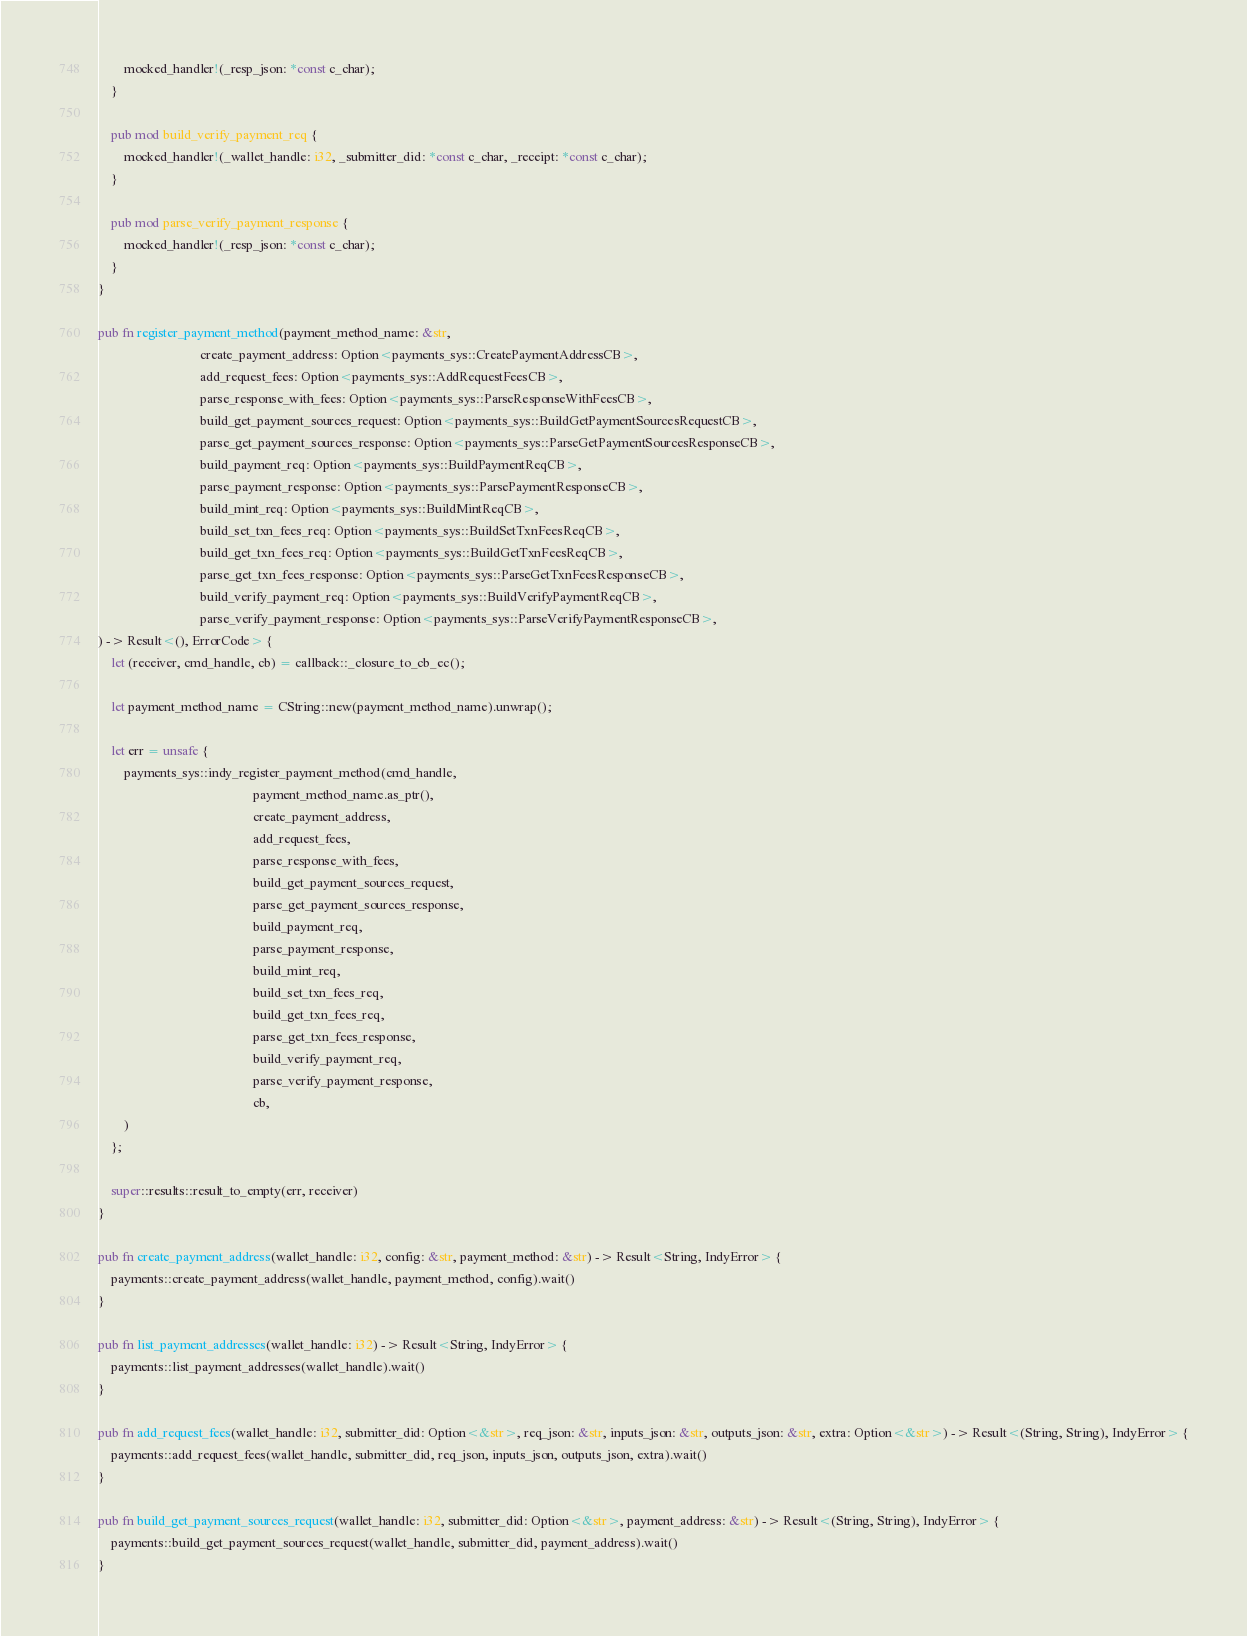Convert code to text. <code><loc_0><loc_0><loc_500><loc_500><_Rust_>        mocked_handler!(_resp_json: *const c_char);
    }

    pub mod build_verify_payment_req {
        mocked_handler!(_wallet_handle: i32, _submitter_did: *const c_char, _receipt: *const c_char);
    }

    pub mod parse_verify_payment_response {
        mocked_handler!(_resp_json: *const c_char);
    }
}

pub fn register_payment_method(payment_method_name: &str,
                               create_payment_address: Option<payments_sys::CreatePaymentAddressCB>,
                               add_request_fees: Option<payments_sys::AddRequestFeesCB>,
                               parse_response_with_fees: Option<payments_sys::ParseResponseWithFeesCB>,
                               build_get_payment_sources_request: Option<payments_sys::BuildGetPaymentSourcesRequestCB>,
                               parse_get_payment_sources_response: Option<payments_sys::ParseGetPaymentSourcesResponseCB>,
                               build_payment_req: Option<payments_sys::BuildPaymentReqCB>,
                               parse_payment_response: Option<payments_sys::ParsePaymentResponseCB>,
                               build_mint_req: Option<payments_sys::BuildMintReqCB>,
                               build_set_txn_fees_req: Option<payments_sys::BuildSetTxnFeesReqCB>,
                               build_get_txn_fees_req: Option<payments_sys::BuildGetTxnFeesReqCB>,
                               parse_get_txn_fees_response: Option<payments_sys::ParseGetTxnFeesResponseCB>,
                               build_verify_payment_req: Option<payments_sys::BuildVerifyPaymentReqCB>,
                               parse_verify_payment_response: Option<payments_sys::ParseVerifyPaymentResponseCB>,
) -> Result<(), ErrorCode> {
    let (receiver, cmd_handle, cb) = callback::_closure_to_cb_ec();

    let payment_method_name = CString::new(payment_method_name).unwrap();

    let err = unsafe {
        payments_sys::indy_register_payment_method(cmd_handle,
                                               payment_method_name.as_ptr(),
                                               create_payment_address,
                                               add_request_fees,
                                               parse_response_with_fees,
                                               build_get_payment_sources_request,
                                               parse_get_payment_sources_response,
                                               build_payment_req,
                                               parse_payment_response,
                                               build_mint_req,
                                               build_set_txn_fees_req,
                                               build_get_txn_fees_req,
                                               parse_get_txn_fees_response,
                                               build_verify_payment_req,
                                               parse_verify_payment_response,
                                               cb,
        )
    };

    super::results::result_to_empty(err, receiver)
}

pub fn create_payment_address(wallet_handle: i32, config: &str, payment_method: &str) -> Result<String, IndyError> {
    payments::create_payment_address(wallet_handle, payment_method, config).wait()
}

pub fn list_payment_addresses(wallet_handle: i32) -> Result<String, IndyError> {
    payments::list_payment_addresses(wallet_handle).wait()
}

pub fn add_request_fees(wallet_handle: i32, submitter_did: Option<&str>, req_json: &str, inputs_json: &str, outputs_json: &str, extra: Option<&str>) -> Result<(String, String), IndyError> {
    payments::add_request_fees(wallet_handle, submitter_did, req_json, inputs_json, outputs_json, extra).wait()
}

pub fn build_get_payment_sources_request(wallet_handle: i32, submitter_did: Option<&str>, payment_address: &str) -> Result<(String, String), IndyError> {
    payments::build_get_payment_sources_request(wallet_handle, submitter_did, payment_address).wait()
}
</code> 